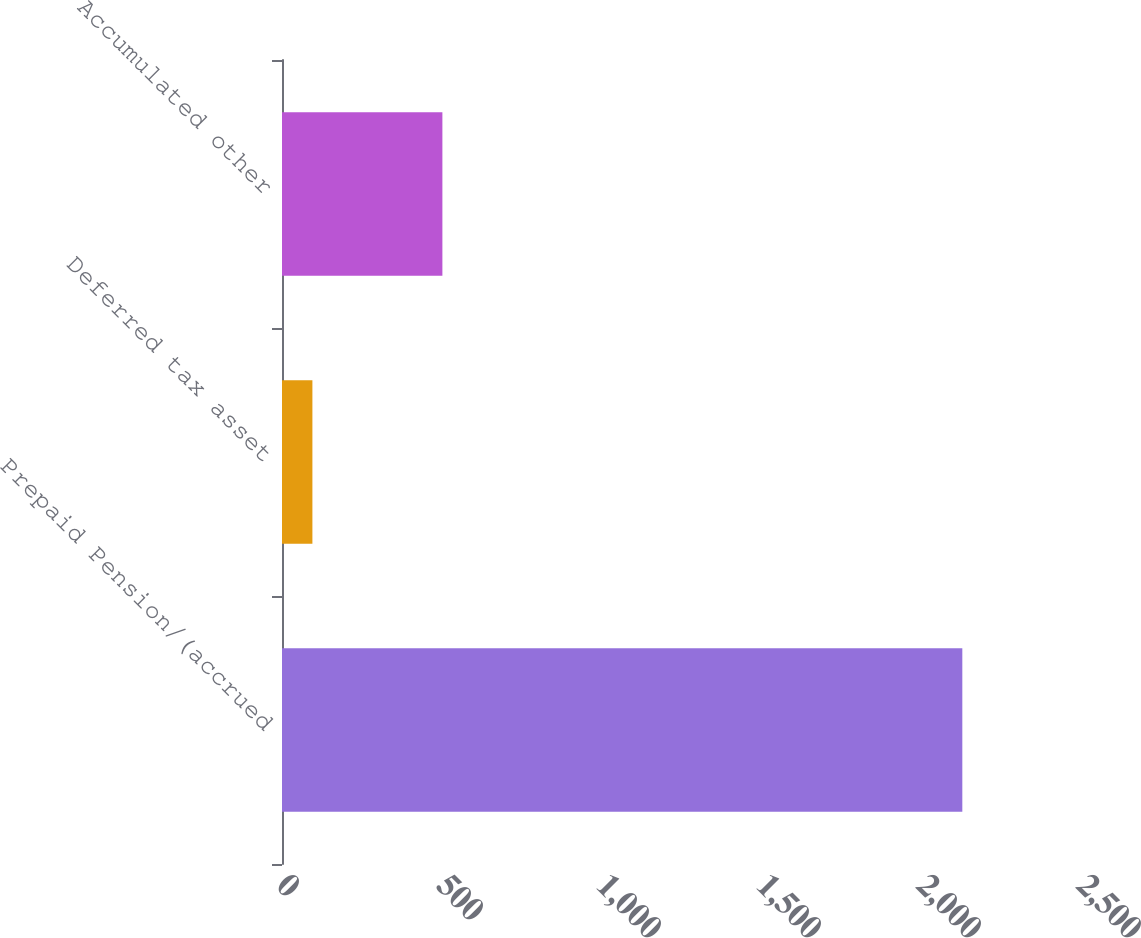<chart> <loc_0><loc_0><loc_500><loc_500><bar_chart><fcel>Prepaid Pension/(accrued<fcel>Deferred tax asset<fcel>Accumulated other<nl><fcel>2126<fcel>95<fcel>501.2<nl></chart> 